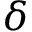<formula> <loc_0><loc_0><loc_500><loc_500>\delta</formula> 